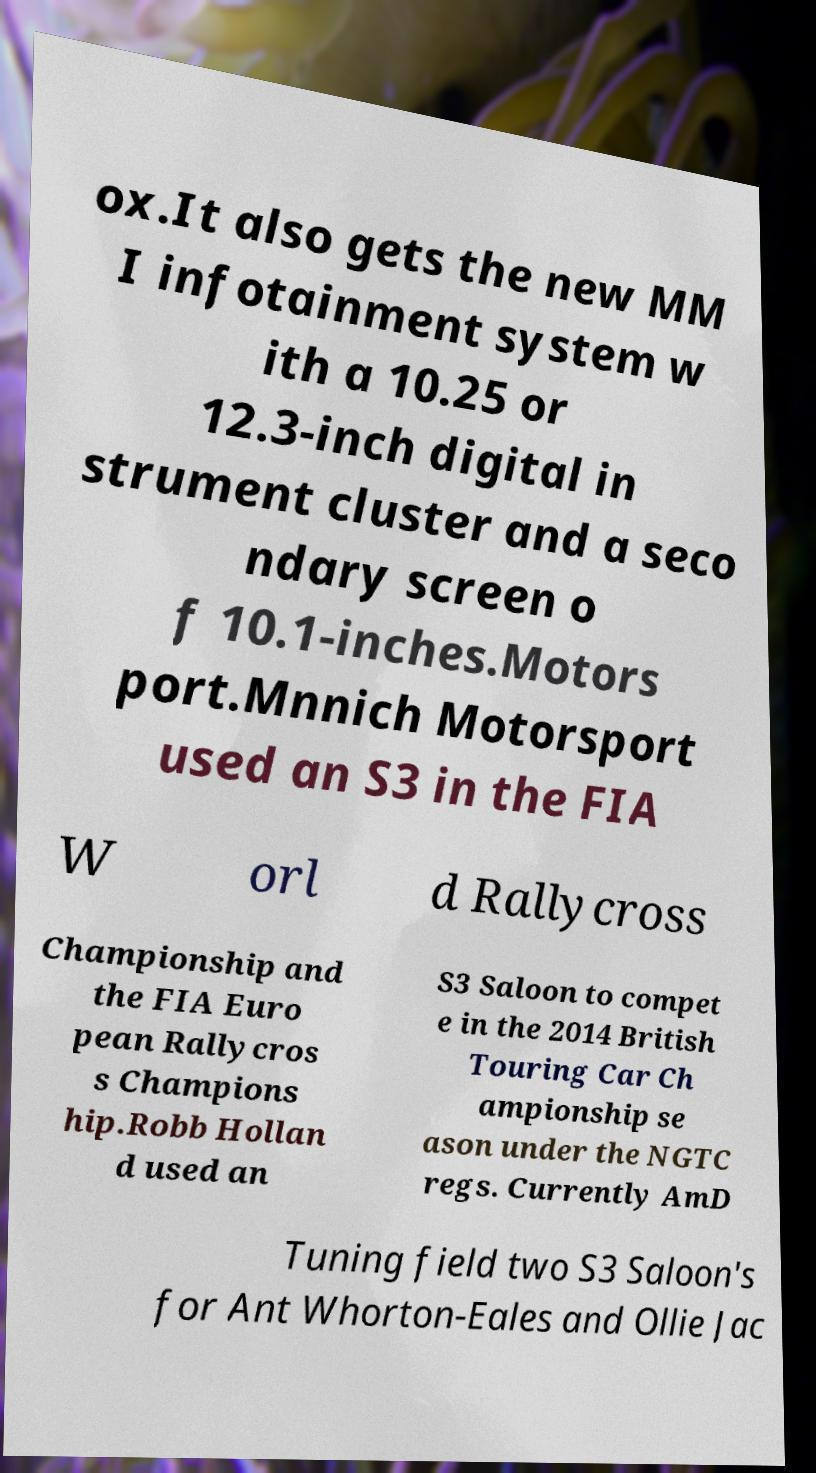Could you extract and type out the text from this image? ox.It also gets the new MM I infotainment system w ith a 10.25 or 12.3-inch digital in strument cluster and a seco ndary screen o f 10.1-inches.Motors port.Mnnich Motorsport used an S3 in the FIA W orl d Rallycross Championship and the FIA Euro pean Rallycros s Champions hip.Robb Hollan d used an S3 Saloon to compet e in the 2014 British Touring Car Ch ampionship se ason under the NGTC regs. Currently AmD Tuning field two S3 Saloon's for Ant Whorton-Eales and Ollie Jac 